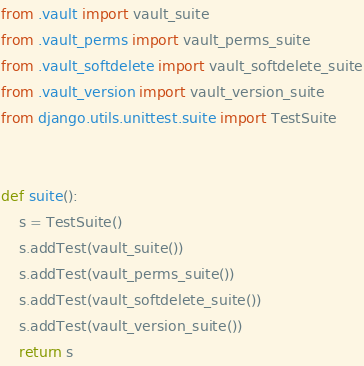<code> <loc_0><loc_0><loc_500><loc_500><_Python_>from .vault import vault_suite
from .vault_perms import vault_perms_suite
from .vault_softdelete import vault_softdelete_suite
from .vault_version import vault_version_suite
from django.utils.unittest.suite import TestSuite


def suite():
    s = TestSuite()
    s.addTest(vault_suite())
    s.addTest(vault_perms_suite())
    s.addTest(vault_softdelete_suite())
    s.addTest(vault_version_suite())
    return s
</code> 